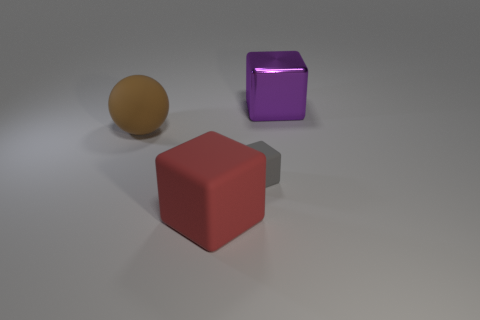Does the large red matte object in front of the gray rubber block have the same shape as the metallic thing?
Your answer should be compact. Yes. What number of objects are things behind the large brown sphere or large gray shiny balls?
Your answer should be compact. 1. Is there a brown matte object of the same shape as the purple thing?
Give a very brief answer. No. There is a red rubber thing that is the same size as the purple object; what shape is it?
Make the answer very short. Cube. What shape is the big object right of the rubber block behind the large object that is in front of the tiny gray rubber thing?
Provide a short and direct response. Cube. Does the large red object have the same shape as the object right of the gray block?
Ensure brevity in your answer.  Yes. How many large things are either red rubber balls or red rubber things?
Your response must be concise. 1. Are there any objects that have the same size as the gray matte cube?
Ensure brevity in your answer.  No. The cube right of the matte thing that is on the right side of the big block that is in front of the large purple object is what color?
Your answer should be very brief. Purple. Is the material of the big red cube the same as the large thing that is right of the red block?
Provide a succinct answer. No. 